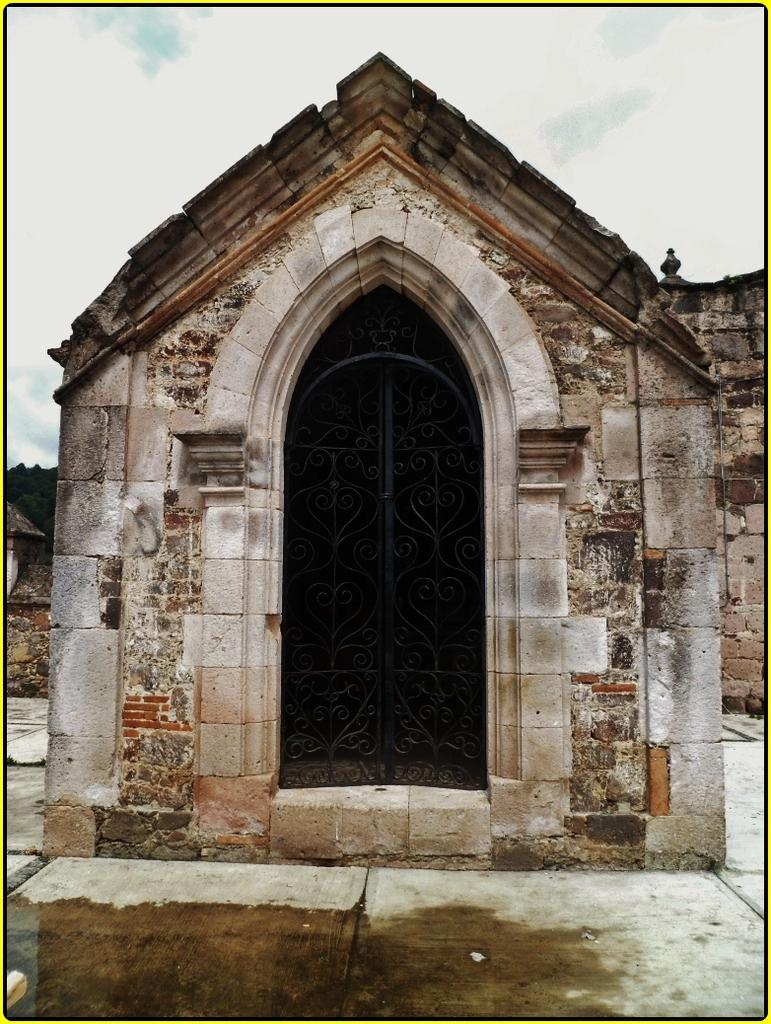What type of space is shown in the image? The image depicts a small room. Are there any specific features in the room? Yes, there are doors in the room. What is the condition of the floor in the room? There is water on the floor in the image. What can be seen in the background of the room? There is a wall visible in the background, along with trees and clouds in the sky. What type of nerve activity can be observed in the image? There is no nerve activity present in the image; it depicts a small room with water on the floor and a background with trees and clouds. What type of card game is being played in the image? There is no card game or any indication of a game being played in the image. 